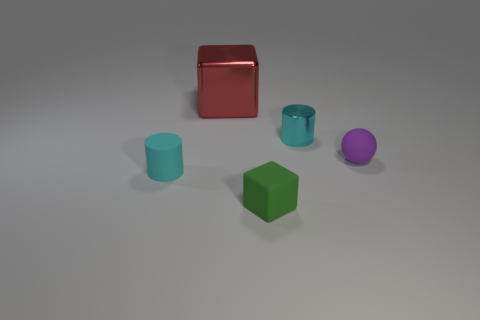Are there any other things that have the same material as the green block?
Your answer should be compact. Yes. There is a small matte object that is in front of the cyan cylinder in front of the small cylinder right of the rubber cube; what is its color?
Your answer should be very brief. Green. There is a small cyan cylinder in front of the rubber sphere; is there a thing that is in front of it?
Your answer should be very brief. Yes. Is the shape of the metallic object in front of the shiny cube the same as  the cyan matte object?
Provide a succinct answer. Yes. Is there any other thing that is the same shape as the small purple thing?
Offer a terse response. No. How many blocks are things or small cyan matte objects?
Provide a short and direct response. 2. How many large red balls are there?
Make the answer very short. 0. There is a block behind the tiny cyan cylinder that is to the left of the large metallic block; what size is it?
Offer a very short reply. Large. What number of other things are the same size as the red shiny thing?
Provide a succinct answer. 0. How many small purple spheres are behind the tiny cyan matte thing?
Your answer should be very brief. 1. 